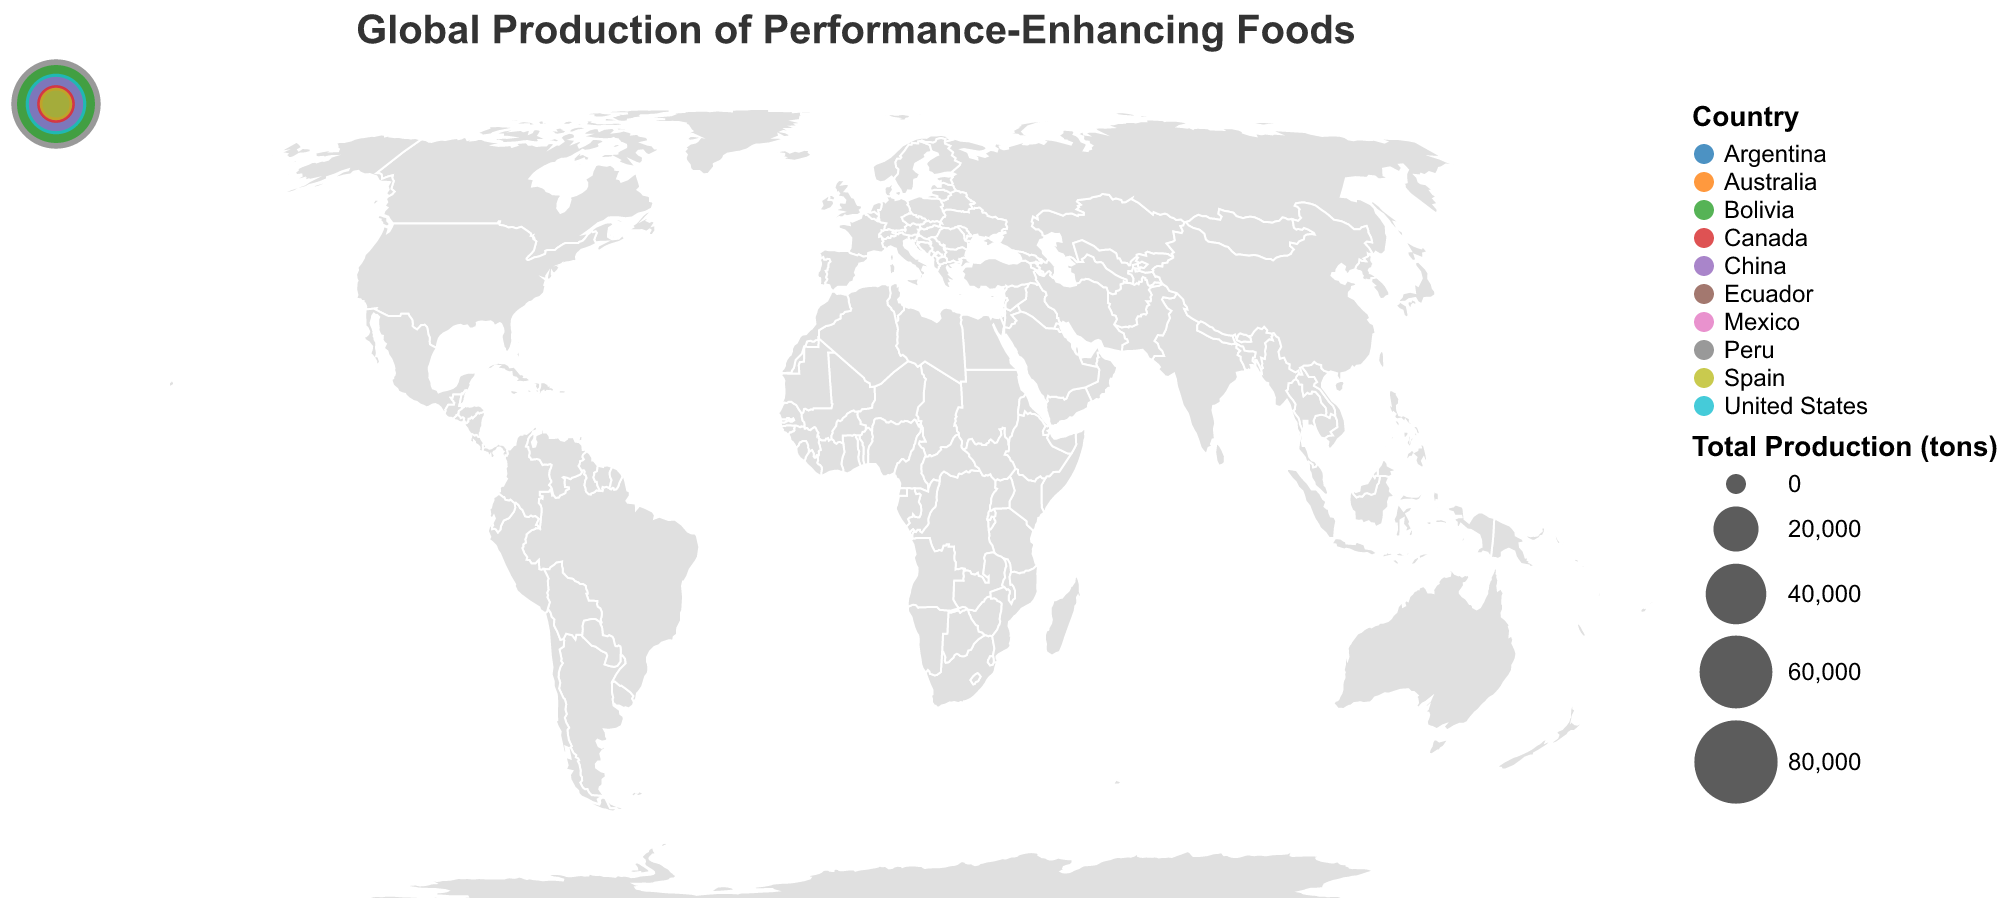What is the title of the figure? The title is usually at the top of the figure and provides a summary of what the plot represents. In this case, the title is "Global Production of Performance-Enhancing Foods."
Answer: Global Production of Performance-Enhancing Foods Which country produces the most quinoa? Look at the circles on the map and the tooltip that appears when you hover over each country. The size of the circle represents the total production. Peru has the largest circle, indicating the highest production of quinoa with 86,000 tons.
Answer: Peru Which country produces the least kale? Again, by examining the tooltips or the sizes of circles linked to countries on the plot, Spain appears to have one of the smaller circles when it comes to kale production, with only 7,000 tons. However, Ecuador has the least with 2,000 tons.
Answer: Ecuador How does the chia seed production in Australia compare to that in the United States? Check the values indicated in the tooltips for both countries. Australia produces 8,000 tons of chia seeds, while the United States produces 15,000 tons. Thus, the U.S. produces more chia seeds than Australia.
Answer: The U.S. produces more chia seeds than Australia What is the total production of quinoa across all countries? Sum up the quinoa production values for each country: 86,000 (Peru) + 65,000 (Bolivia) + 3,000 (Ecuador) + 5,000 (United States) + 700 (Australia) + 200 (China) + 100 (Mexico) + 1,500 (Canada) + 200 (Argentina) + 50 (Spain) = 161,750 tons.
Answer: 161,750 tons Which country has the second highest total production of these foods? By looking at the total production values calculated in the plot tooltips, the United States has the highest total production with 40,000 tons, and China has the second highest with around 31,200 tons.
Answer: China What are the three countries with the lowest total production? Check each country's total production by summing quinoa, chia seeds, and kale for each: Argentina (4,200), Spain (8,050), and Ecuador (5,500) have the lowest totals.
Answer: Argentina, Spain, Ecuador What's the average production of chia seeds across all countries? Sum up all chia seed production and divide by the number of countries: (2,000 + 1,500 + 500 + 15,000 + 8,000 + 1,000 + 3,000 + 5,000 + 2,500 + 1,000)/10 = 3,750 tons.
Answer: 3,750 tons 